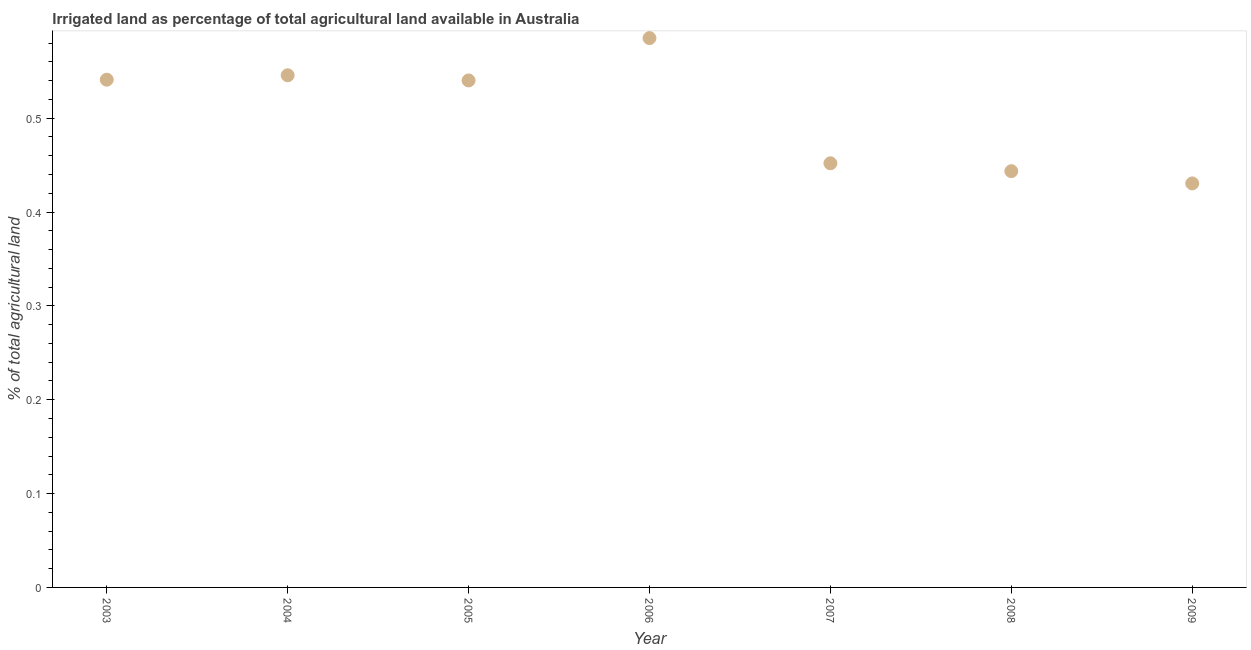What is the percentage of agricultural irrigated land in 2007?
Offer a terse response. 0.45. Across all years, what is the maximum percentage of agricultural irrigated land?
Provide a short and direct response. 0.59. Across all years, what is the minimum percentage of agricultural irrigated land?
Your answer should be compact. 0.43. In which year was the percentage of agricultural irrigated land maximum?
Your response must be concise. 2006. In which year was the percentage of agricultural irrigated land minimum?
Give a very brief answer. 2009. What is the sum of the percentage of agricultural irrigated land?
Ensure brevity in your answer.  3.54. What is the difference between the percentage of agricultural irrigated land in 2003 and 2007?
Offer a terse response. 0.09. What is the average percentage of agricultural irrigated land per year?
Your answer should be compact. 0.51. What is the median percentage of agricultural irrigated land?
Give a very brief answer. 0.54. What is the ratio of the percentage of agricultural irrigated land in 2006 to that in 2009?
Make the answer very short. 1.36. Is the percentage of agricultural irrigated land in 2003 less than that in 2009?
Make the answer very short. No. What is the difference between the highest and the second highest percentage of agricultural irrigated land?
Provide a succinct answer. 0.04. Is the sum of the percentage of agricultural irrigated land in 2007 and 2009 greater than the maximum percentage of agricultural irrigated land across all years?
Your answer should be compact. Yes. What is the difference between the highest and the lowest percentage of agricultural irrigated land?
Give a very brief answer. 0.15. How many years are there in the graph?
Your answer should be compact. 7. What is the title of the graph?
Make the answer very short. Irrigated land as percentage of total agricultural land available in Australia. What is the label or title of the Y-axis?
Provide a short and direct response. % of total agricultural land. What is the % of total agricultural land in 2003?
Make the answer very short. 0.54. What is the % of total agricultural land in 2004?
Offer a terse response. 0.55. What is the % of total agricultural land in 2005?
Your answer should be very brief. 0.54. What is the % of total agricultural land in 2006?
Offer a terse response. 0.59. What is the % of total agricultural land in 2007?
Your answer should be compact. 0.45. What is the % of total agricultural land in 2008?
Provide a short and direct response. 0.44. What is the % of total agricultural land in 2009?
Offer a terse response. 0.43. What is the difference between the % of total agricultural land in 2003 and 2004?
Offer a terse response. -0. What is the difference between the % of total agricultural land in 2003 and 2005?
Offer a very short reply. 0. What is the difference between the % of total agricultural land in 2003 and 2006?
Your response must be concise. -0.04. What is the difference between the % of total agricultural land in 2003 and 2007?
Provide a succinct answer. 0.09. What is the difference between the % of total agricultural land in 2003 and 2008?
Give a very brief answer. 0.1. What is the difference between the % of total agricultural land in 2003 and 2009?
Ensure brevity in your answer.  0.11. What is the difference between the % of total agricultural land in 2004 and 2005?
Ensure brevity in your answer.  0.01. What is the difference between the % of total agricultural land in 2004 and 2006?
Make the answer very short. -0.04. What is the difference between the % of total agricultural land in 2004 and 2007?
Offer a very short reply. 0.09. What is the difference between the % of total agricultural land in 2004 and 2008?
Provide a succinct answer. 0.1. What is the difference between the % of total agricultural land in 2004 and 2009?
Give a very brief answer. 0.12. What is the difference between the % of total agricultural land in 2005 and 2006?
Keep it short and to the point. -0.05. What is the difference between the % of total agricultural land in 2005 and 2007?
Provide a short and direct response. 0.09. What is the difference between the % of total agricultural land in 2005 and 2008?
Your answer should be very brief. 0.1. What is the difference between the % of total agricultural land in 2005 and 2009?
Give a very brief answer. 0.11. What is the difference between the % of total agricultural land in 2006 and 2007?
Give a very brief answer. 0.13. What is the difference between the % of total agricultural land in 2006 and 2008?
Your response must be concise. 0.14. What is the difference between the % of total agricultural land in 2006 and 2009?
Keep it short and to the point. 0.15. What is the difference between the % of total agricultural land in 2007 and 2008?
Provide a short and direct response. 0.01. What is the difference between the % of total agricultural land in 2007 and 2009?
Provide a short and direct response. 0.02. What is the difference between the % of total agricultural land in 2008 and 2009?
Provide a succinct answer. 0.01. What is the ratio of the % of total agricultural land in 2003 to that in 2004?
Offer a very short reply. 0.99. What is the ratio of the % of total agricultural land in 2003 to that in 2005?
Make the answer very short. 1. What is the ratio of the % of total agricultural land in 2003 to that in 2006?
Your answer should be compact. 0.92. What is the ratio of the % of total agricultural land in 2003 to that in 2007?
Give a very brief answer. 1.2. What is the ratio of the % of total agricultural land in 2003 to that in 2008?
Your response must be concise. 1.22. What is the ratio of the % of total agricultural land in 2003 to that in 2009?
Your answer should be very brief. 1.26. What is the ratio of the % of total agricultural land in 2004 to that in 2006?
Provide a short and direct response. 0.93. What is the ratio of the % of total agricultural land in 2004 to that in 2007?
Ensure brevity in your answer.  1.21. What is the ratio of the % of total agricultural land in 2004 to that in 2008?
Provide a short and direct response. 1.23. What is the ratio of the % of total agricultural land in 2004 to that in 2009?
Provide a succinct answer. 1.27. What is the ratio of the % of total agricultural land in 2005 to that in 2006?
Ensure brevity in your answer.  0.92. What is the ratio of the % of total agricultural land in 2005 to that in 2007?
Your answer should be compact. 1.2. What is the ratio of the % of total agricultural land in 2005 to that in 2008?
Your response must be concise. 1.22. What is the ratio of the % of total agricultural land in 2005 to that in 2009?
Make the answer very short. 1.25. What is the ratio of the % of total agricultural land in 2006 to that in 2007?
Make the answer very short. 1.29. What is the ratio of the % of total agricultural land in 2006 to that in 2008?
Your response must be concise. 1.32. What is the ratio of the % of total agricultural land in 2006 to that in 2009?
Ensure brevity in your answer.  1.36. 